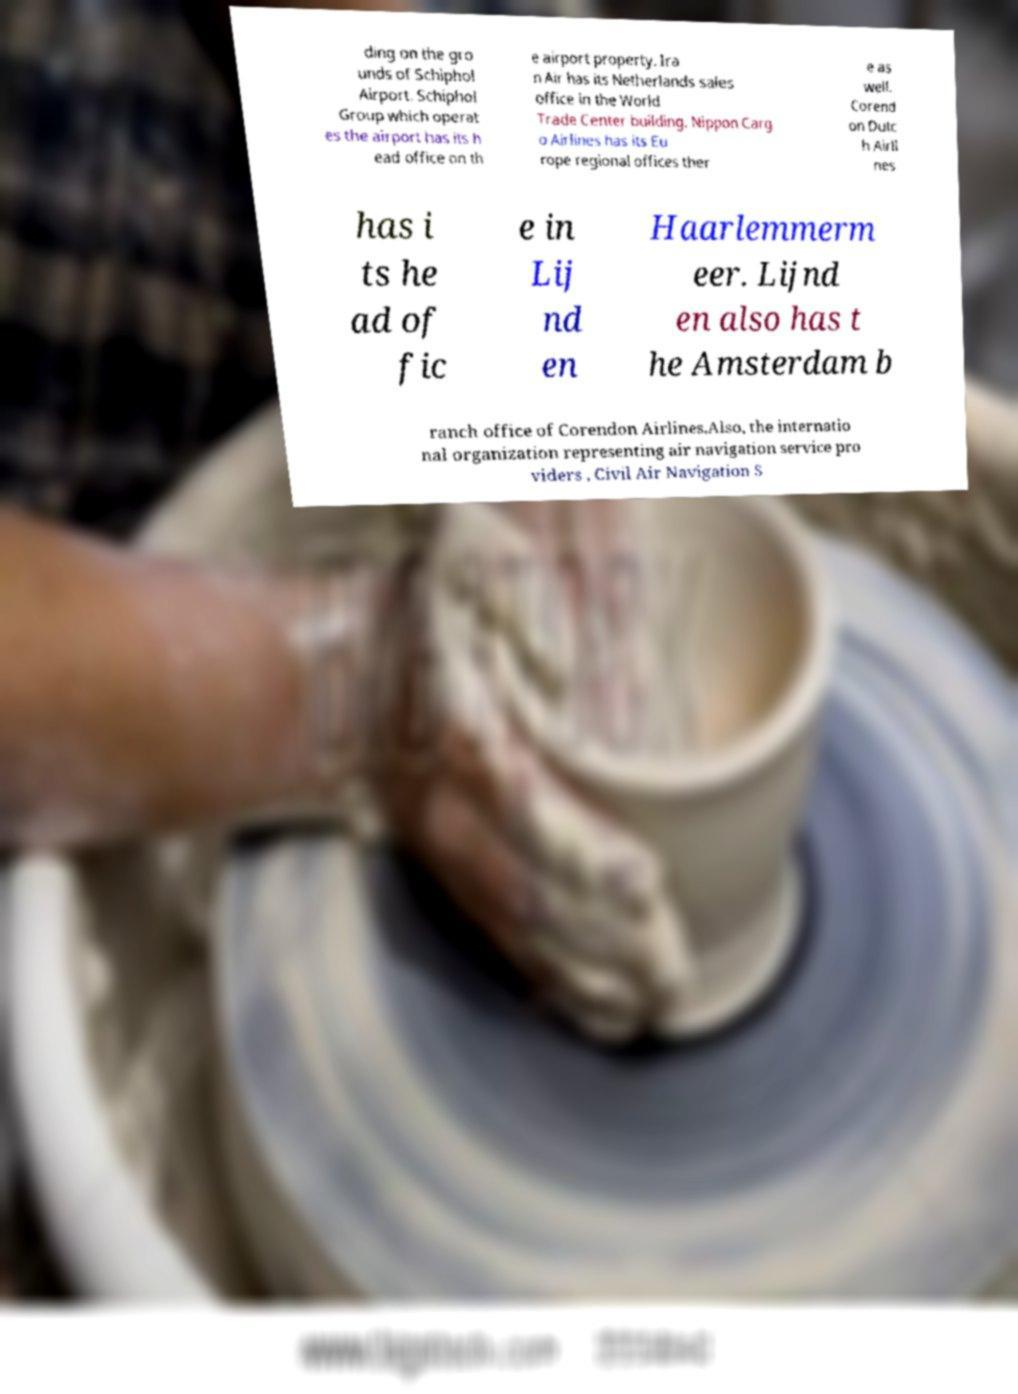Can you accurately transcribe the text from the provided image for me? ding on the gro unds of Schiphol Airport. Schiphol Group which operat es the airport has its h ead office on th e airport property. Ira n Air has its Netherlands sales office in the World Trade Center building. Nippon Carg o Airlines has its Eu rope regional offices ther e as well. Corend on Dutc h Airli nes has i ts he ad of fic e in Lij nd en Haarlemmerm eer. Lijnd en also has t he Amsterdam b ranch office of Corendon Airlines.Also, the internatio nal organization representing air navigation service pro viders , Civil Air Navigation S 